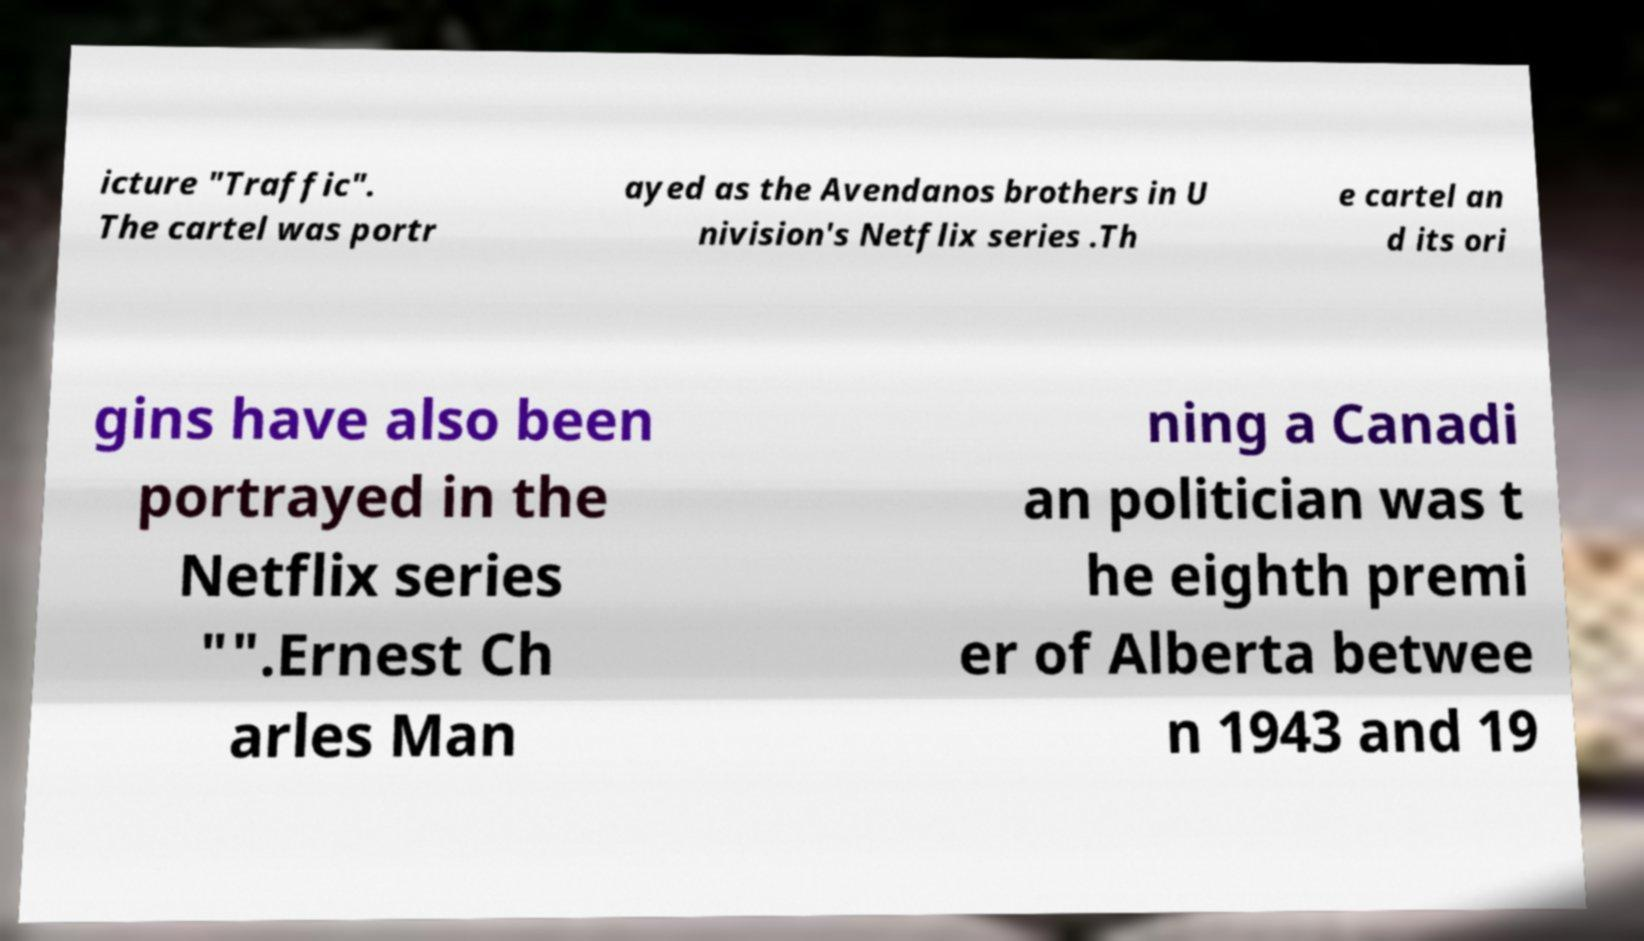What messages or text are displayed in this image? I need them in a readable, typed format. icture "Traffic". The cartel was portr ayed as the Avendanos brothers in U nivision's Netflix series .Th e cartel an d its ori gins have also been portrayed in the Netflix series "".Ernest Ch arles Man ning a Canadi an politician was t he eighth premi er of Alberta betwee n 1943 and 19 